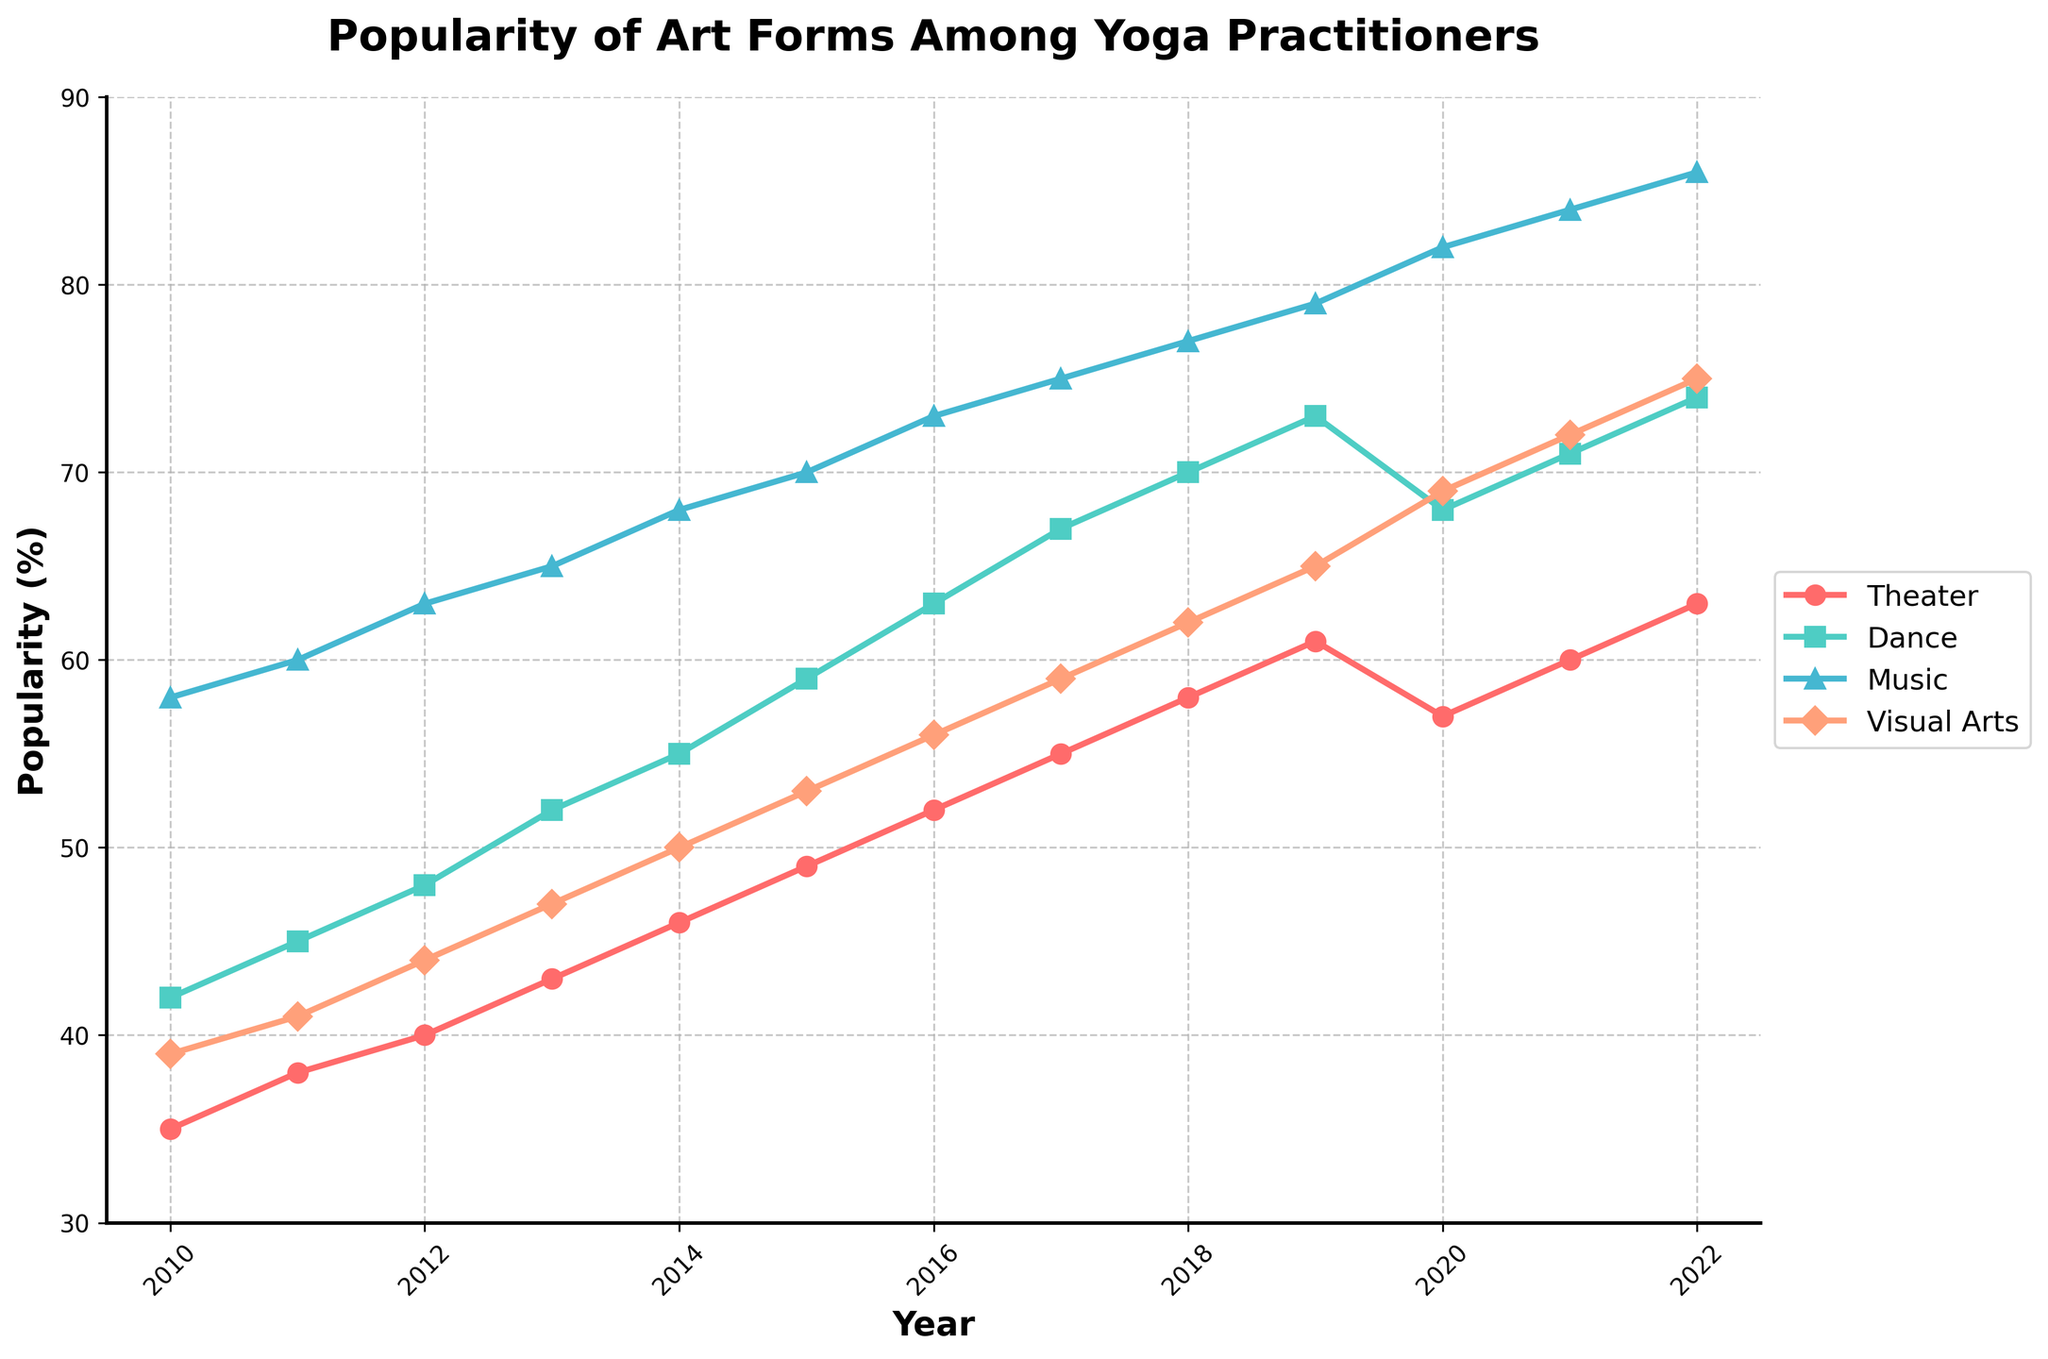Which art form had the highest popularity in 2022? To determine this, we look at the endpoint of each line in the chart for 2022. The 'Music' line is the highest, indicating the highest popularity in that year.
Answer: Music Did the popularity of theater ever decrease between 2010 and 2022? By examining the entire span of the 'Theater' line in the plot, we can see that its line consistently rises without any dips.
Answer: No How does the popularity of dance in 2014 compare to that in 2020? To compare, find the 'Dance' values for 2014 and 2020. The value increases from 55% in 2014 to 68% in 2020.
Answer: Increased What was the average popularity of visual arts from 2019 to 2022? First, sum the values of 'Visual Arts' for the years 2019, 2020, 2021, and 2022 (65, 69, 72, 75), then divide by 4. (65+69+72+75)/4 = 70.25
Answer: 70.25 Which art form showed the most growth in popularity from 2010 to 2022? Calculate the difference for each art form between 2010 and 2022: Theater (63-35=28), Dance (74-42=32), Music (86-58=28), Visual Arts (75-39=36). The highest difference is for Visual Arts, indicating the most growth.
Answer: Visual Arts How did the popularity of music change from 2019 to 2020? Look at the 'Music' values for 2019 and 2020. It increased from 79% to 82%.
Answer: Increased Which year saw the lowest popularity for visual arts? Find the lowest point on the 'Visual Arts' line. The lowest value is 39% in 2010.
Answer: 2010 What is the difference in popularity between dance and theater in 2020? Find the values for 'Dance' and 'Theater' in 2020 (68% and 57%), then subtract the 'Theater' value from the 'Dance' value (68-57=11).
Answer: 11 Which art form had the closest popularity to 70% in 2015? Check values for all art forms in 2015. 'Dance' is closest to 70% with a value of 59%, compared to the others, which deviate more.
Answer: Dance 